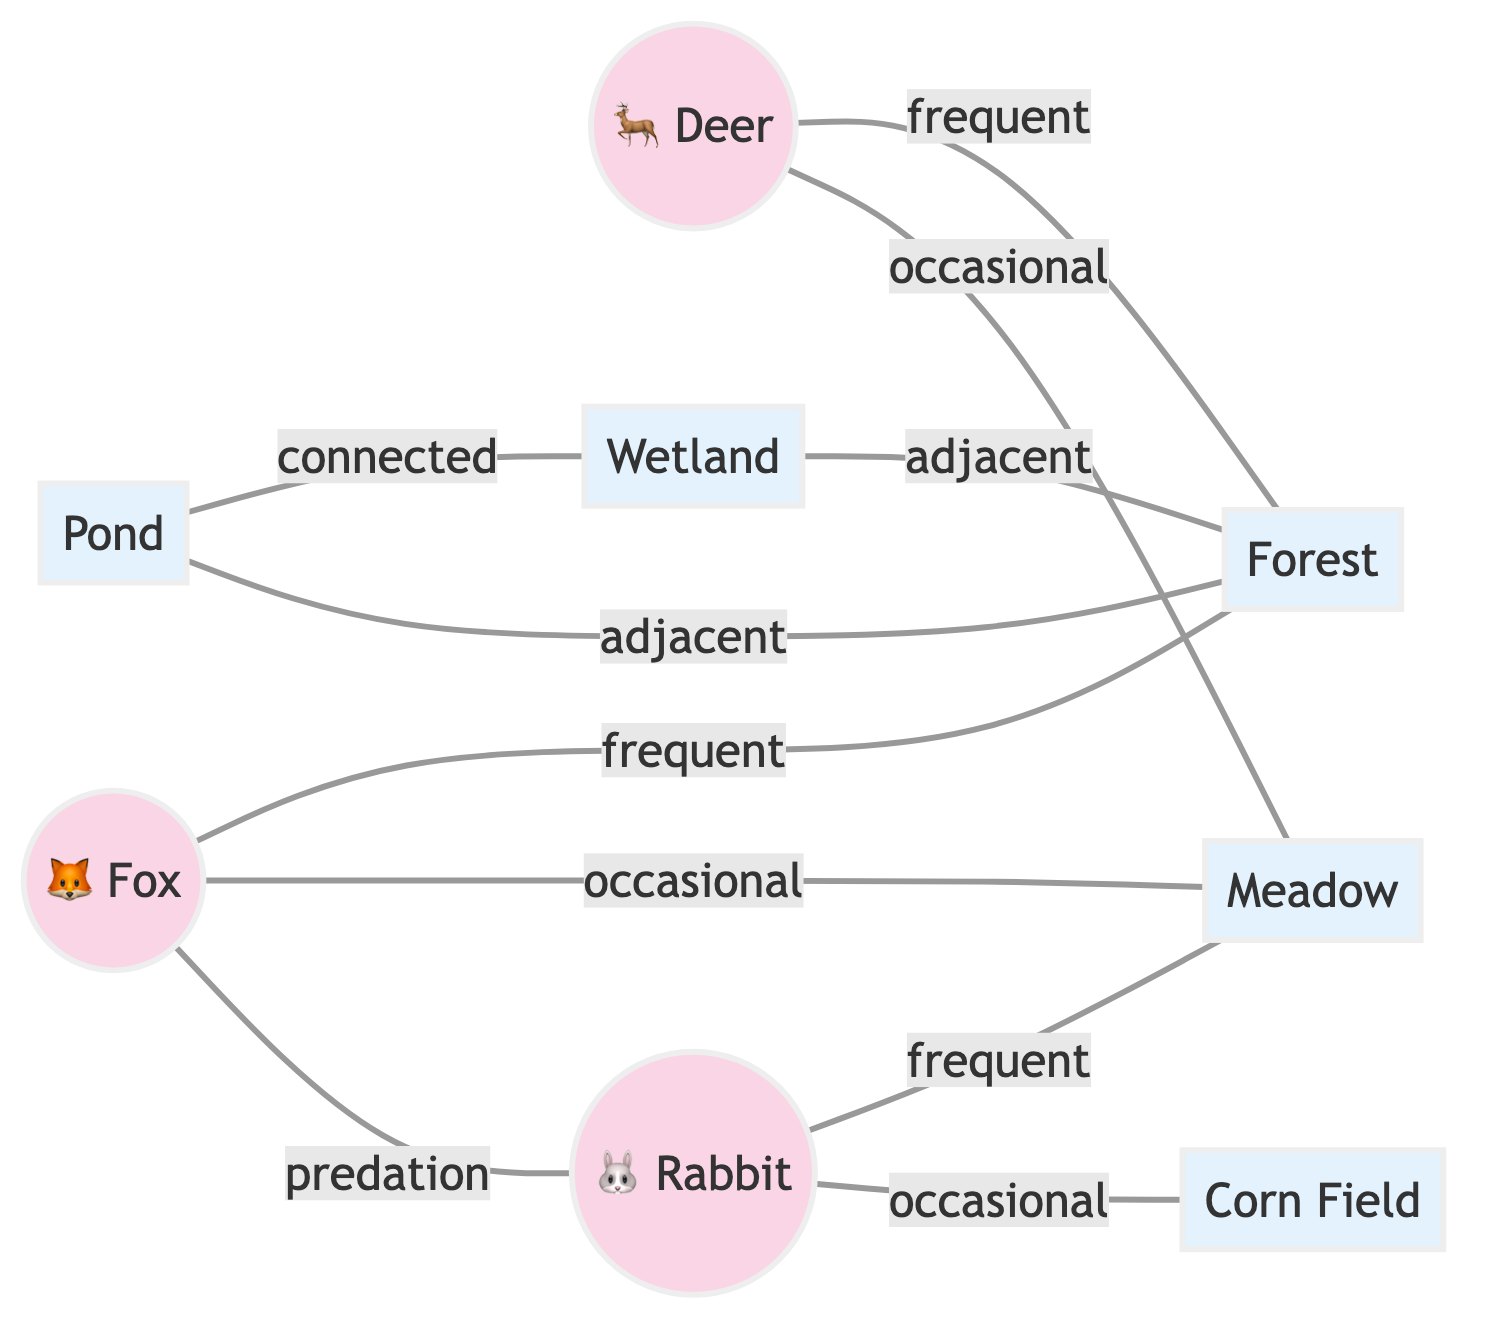What animals are connected to the forest? Looking at the edges that connect to the forest, we can see both the deer and the fox are labeled as "frequent" visitors. The wetland is also adjacent to the forest. Thus, both deer and fox are directly connected as animals to the forest.
Answer: deer, fox How many habitats are there in total? By counting the habitat nodes, we identify five habitats: wetland, forest, meadow, pond, and corn field, giving us a total of five habitats.
Answer: 5 Which animal is associated with predation? The edge labeled "predation" connects the fox to the rabbit, indicating that the fox is the animal involved in the predation relationship with the rabbit.
Answer: fox What is the relationship between the rabbit and the meadow? The edge connects the rabbit to the meadow and is labeled "frequent," indicating that the rabbit frequently visits or inhabits the meadow.
Answer: frequent How many edges connect to the pond? By examining the edges connected to the pond, we find that there are two edges: one to the wetland (connected) and another to the forest (adjacent), indicating that there are two edges in total connecting to the pond.
Answer: 2 Which habitat is occasionally visited by the deer? The edge between the deer and the meadow indicates that the deer visits this habitat occasionally, thus showing the frequency of visitation.
Answer: meadow What is the adjacency relationship of the wetland? The wetland has two adjacent connections: one to the forest and another to the pond, meaning that both habitats are geographically adjacent to the wetland.
Answer: forest, pond How many connections does the fox have? The fox has three connections: frequent to the forest, occasional to the meadow, and predation to the rabbit, resulting in three total connections based on the diagram.
Answer: 3 